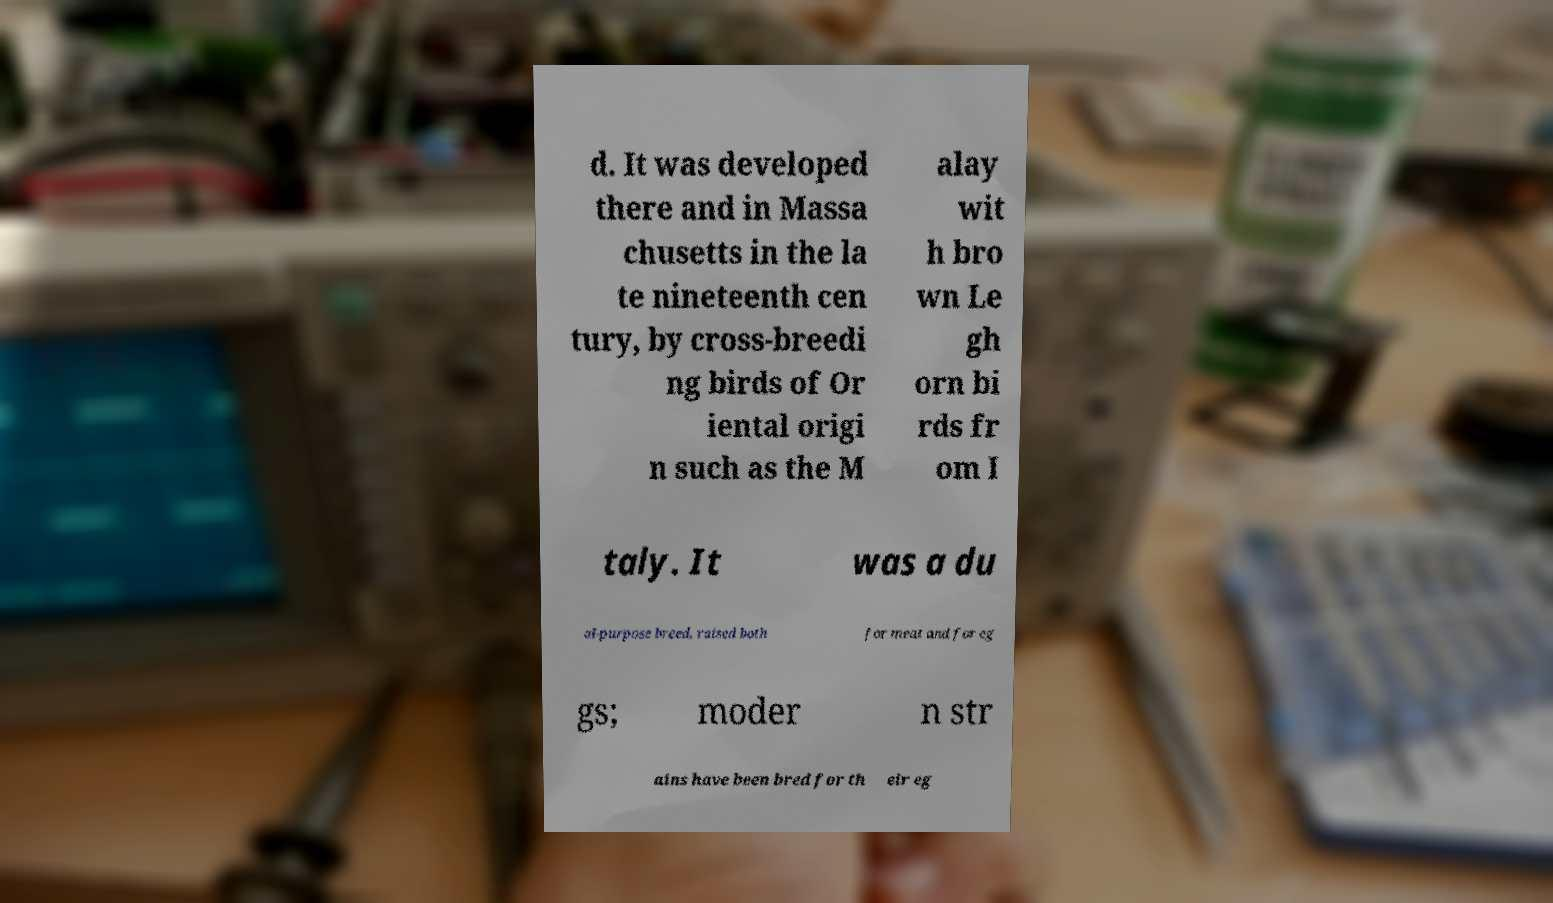Please identify and transcribe the text found in this image. d. It was developed there and in Massa chusetts in the la te nineteenth cen tury, by cross-breedi ng birds of Or iental origi n such as the M alay wit h bro wn Le gh orn bi rds fr om I taly. It was a du al-purpose breed, raised both for meat and for eg gs; moder n str ains have been bred for th eir eg 